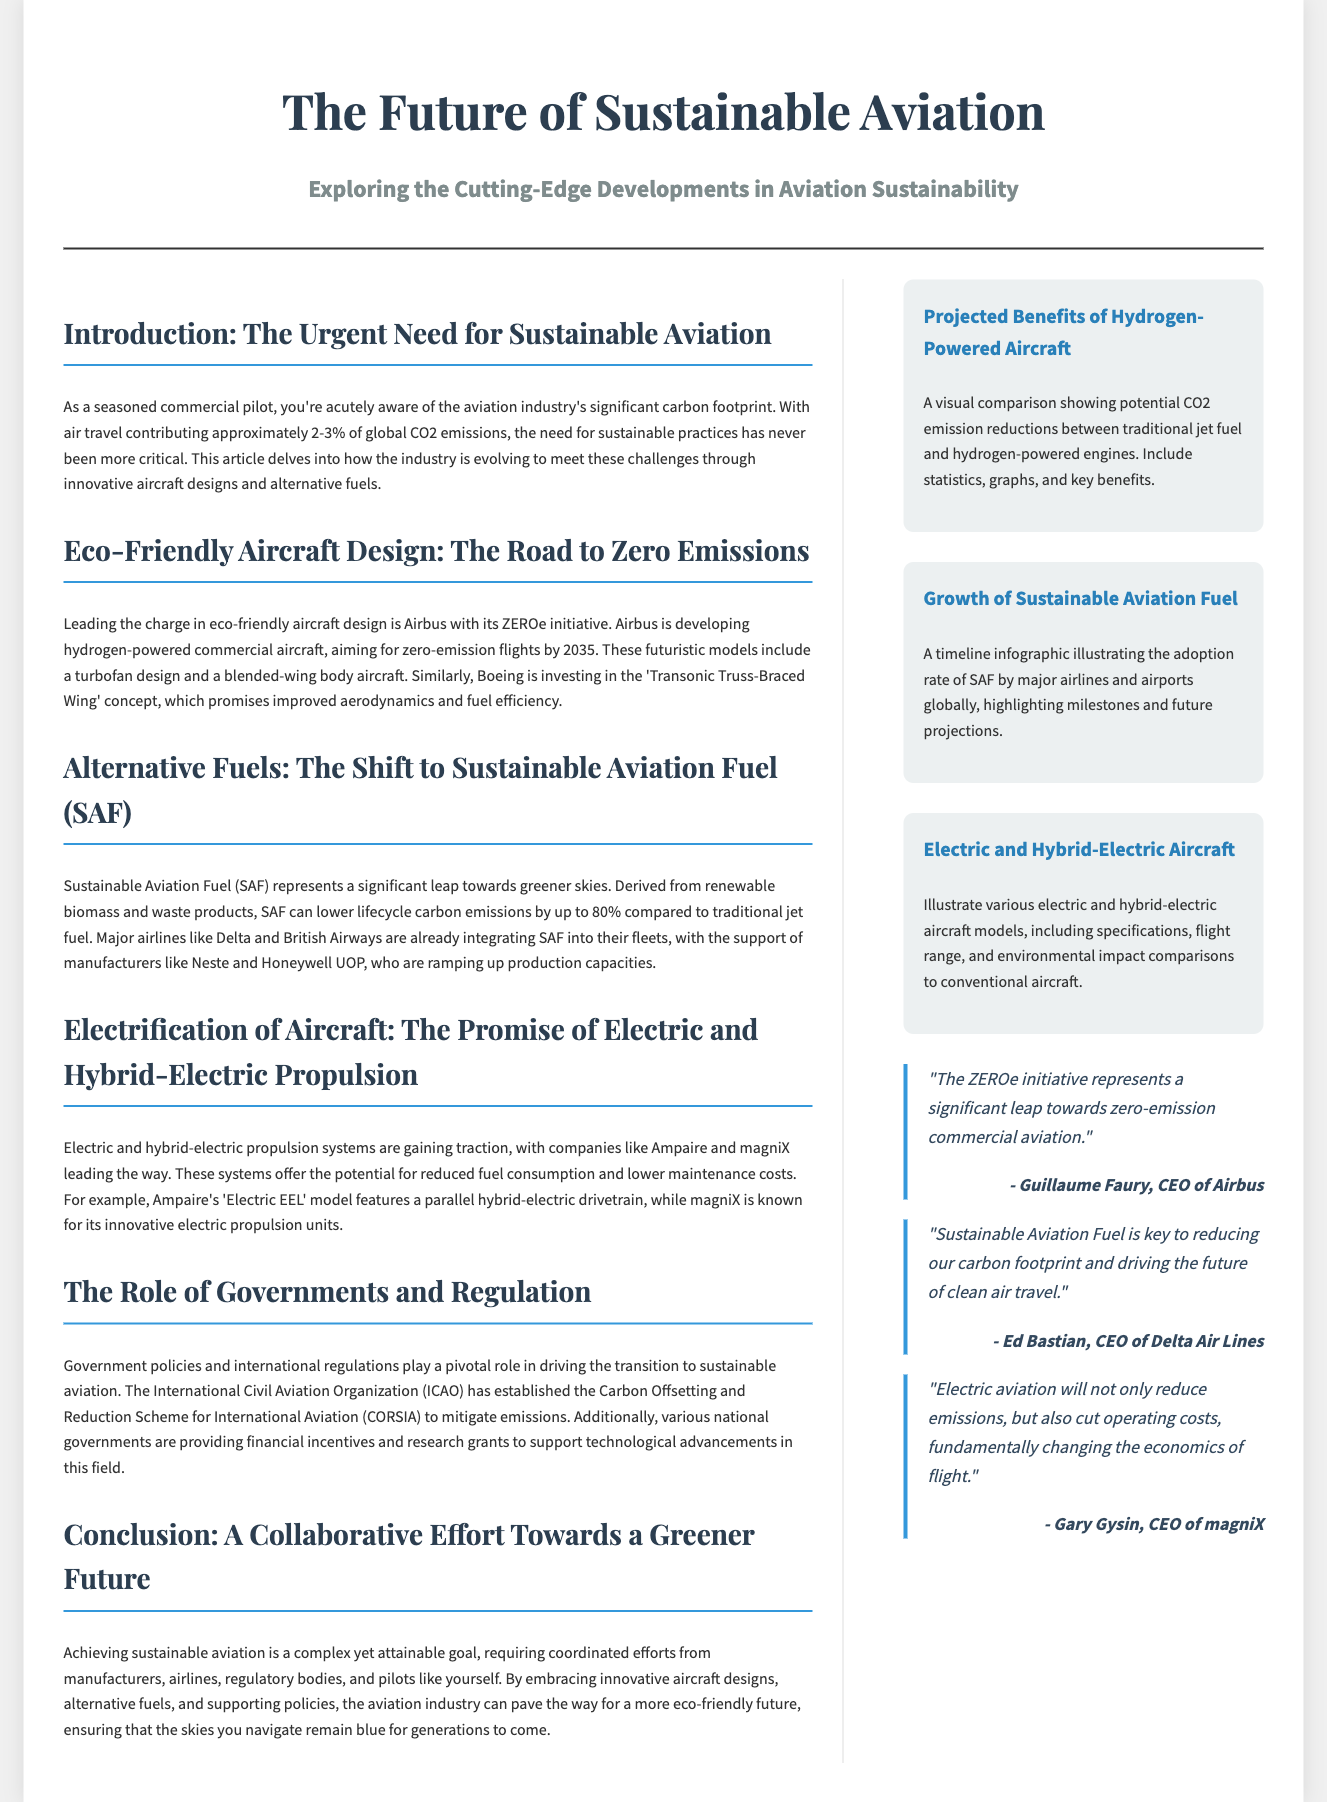what percentage of global CO2 emissions is contributed by air travel? The document states that air travel contributes approximately 2-3% of global CO2 emissions.
Answer: 2-3% what is Airbus's initiative for zero-emission flights? The document mentions Airbus's ZEROe initiative aimed at developing hydrogen-powered commercial aircraft for zero-emission flights by 2035.
Answer: ZEROe who is the CEO of Delta Air Lines? The document provides the quote from Ed Bastian, who is identified as the CEO of Delta Air Lines.
Answer: Ed Bastian what is the potential lifecycle carbon emission reduction of Sustainable Aviation Fuel compared to traditional jet fuel? The document explains that SAF can lower lifecycle carbon emissions by up to 80% compared to traditional jet fuel.
Answer: 80% which company has developed the 'Electric EEL' model? The document mentions Ampaire as the company behind the 'Electric EEL' model featuring a parallel hybrid-electric drivetrain.
Answer: Ampaire what is the primary role of the International Civil Aviation Organization (ICAO) mentioned in the document? The document states that ICAO has established the Carbon Offsetting and Reduction Scheme for International Aviation (CORSIA) to mitigate emissions.
Answer: CORSIA what are the two types of propulsion systems gaining traction in sustainable aviation? The document highlights the rise of electric and hybrid-electric propulsion systems in sustainable aviation.
Answer: Electric and hybrid-electric what year does Airbus aim to achieve zero-emission flights? The document indicates that Airbus aims for zero-emission flights by the year 2035.
Answer: 2035 